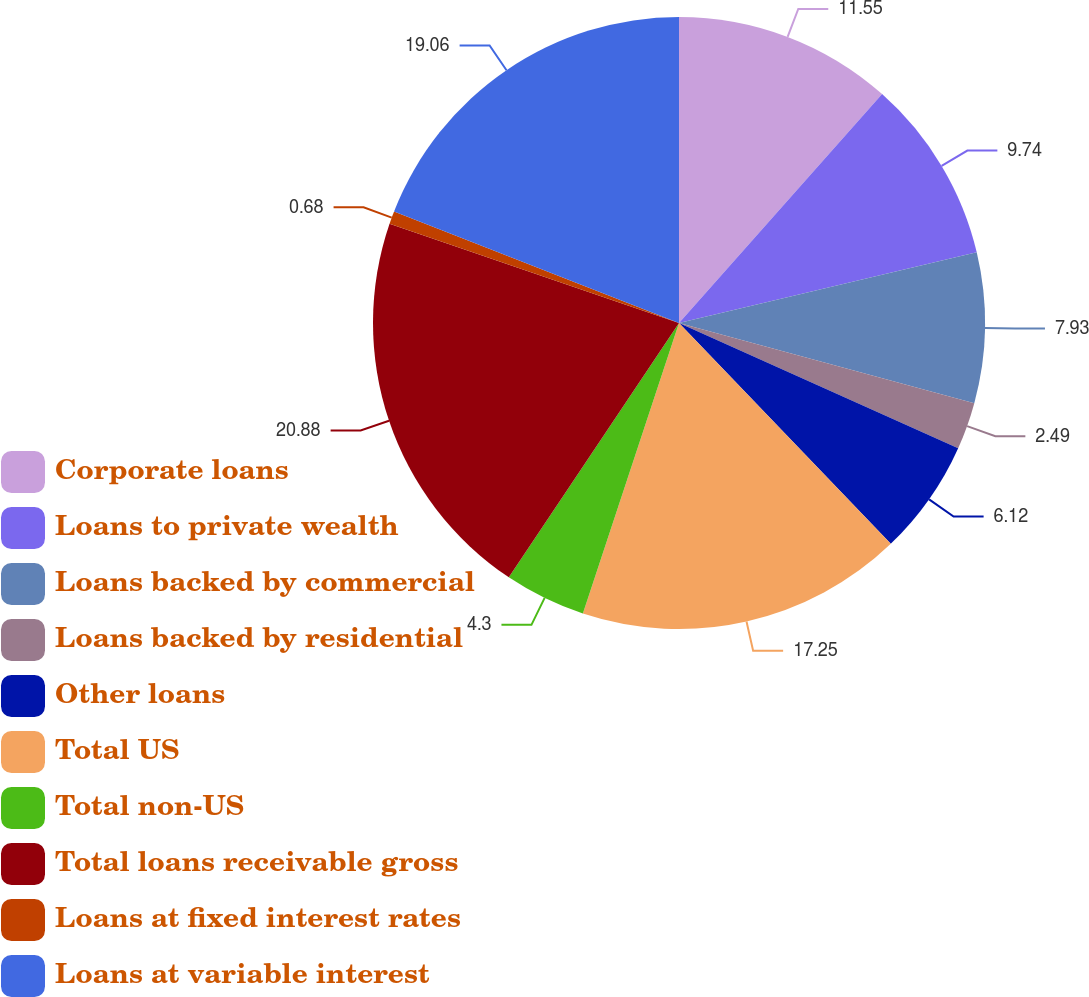Convert chart. <chart><loc_0><loc_0><loc_500><loc_500><pie_chart><fcel>Corporate loans<fcel>Loans to private wealth<fcel>Loans backed by commercial<fcel>Loans backed by residential<fcel>Other loans<fcel>Total US<fcel>Total non-US<fcel>Total loans receivable gross<fcel>Loans at fixed interest rates<fcel>Loans at variable interest<nl><fcel>11.55%<fcel>9.74%<fcel>7.93%<fcel>2.49%<fcel>6.12%<fcel>17.25%<fcel>4.3%<fcel>20.87%<fcel>0.68%<fcel>19.06%<nl></chart> 